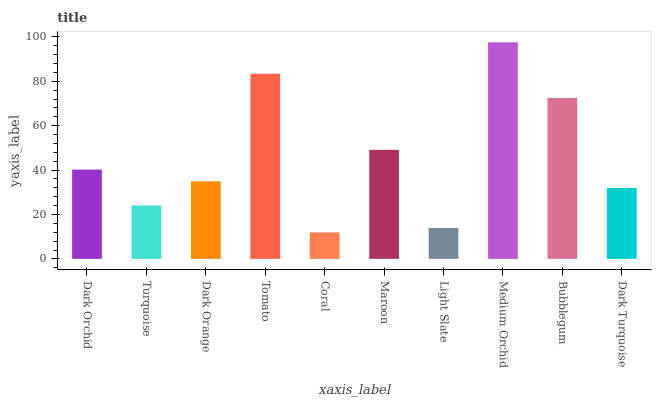Is Coral the minimum?
Answer yes or no. Yes. Is Medium Orchid the maximum?
Answer yes or no. Yes. Is Turquoise the minimum?
Answer yes or no. No. Is Turquoise the maximum?
Answer yes or no. No. Is Dark Orchid greater than Turquoise?
Answer yes or no. Yes. Is Turquoise less than Dark Orchid?
Answer yes or no. Yes. Is Turquoise greater than Dark Orchid?
Answer yes or no. No. Is Dark Orchid less than Turquoise?
Answer yes or no. No. Is Dark Orchid the high median?
Answer yes or no. Yes. Is Dark Orange the low median?
Answer yes or no. Yes. Is Medium Orchid the high median?
Answer yes or no. No. Is Dark Turquoise the low median?
Answer yes or no. No. 